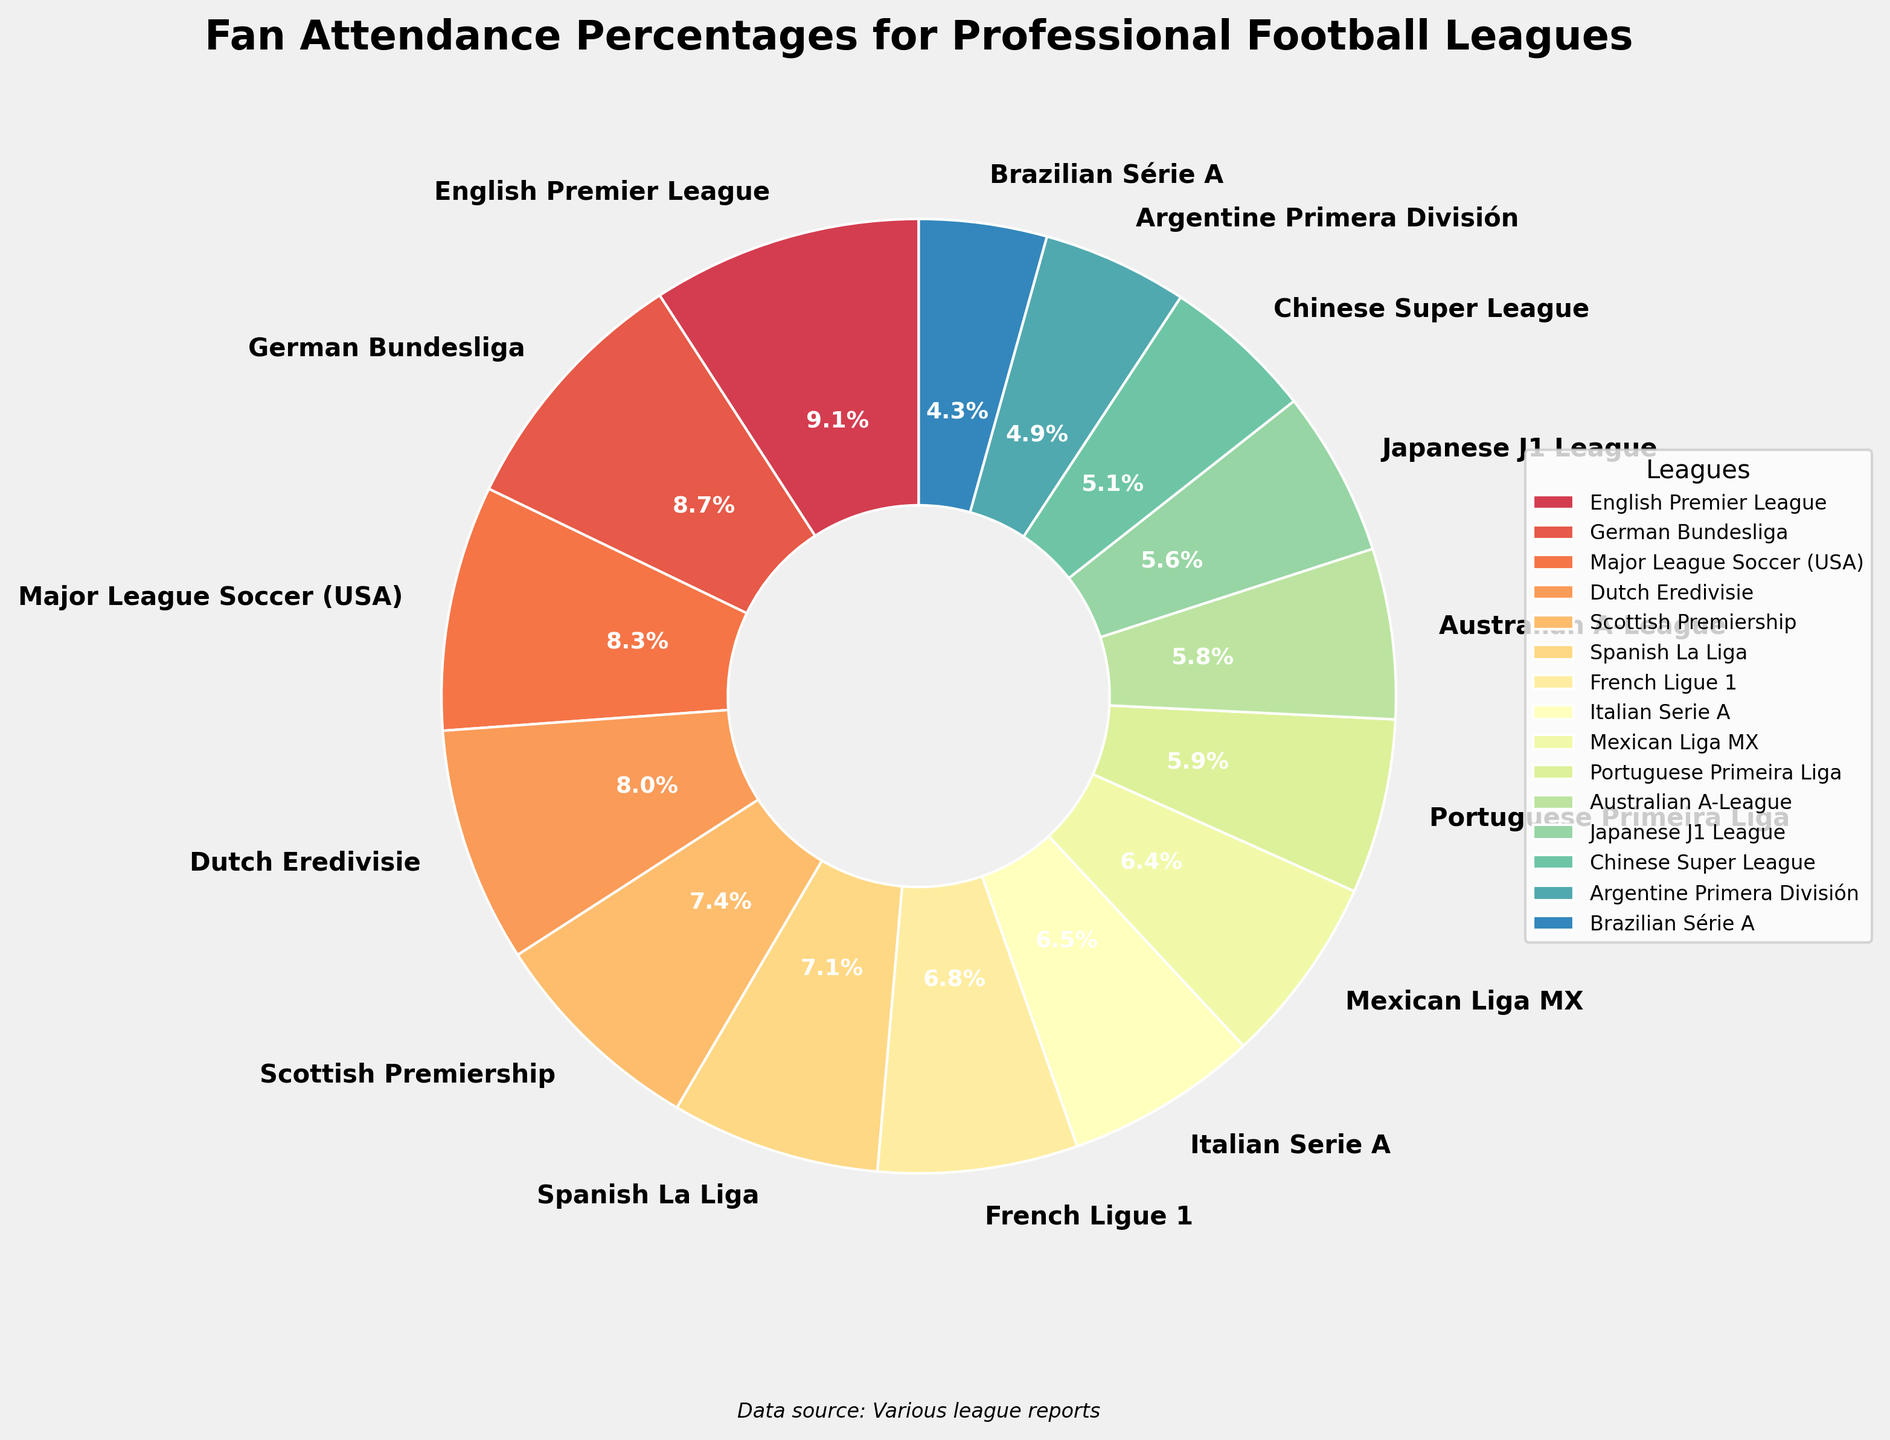Which league has the highest fan attendance percentage? To find the highest fan attendance percentage, look for the league with the largest slice in the pie chart and check its label. The English Premier League has the largest slice with 96.2%.
Answer: English Premier League Which league has the lowest attendance percentage? Identify the smallest slice in the pie chart and look at its label. The Brazilian Série A has the smallest slice with 45.6%.
Answer: Brazilian Série A What's the difference in attendance percentage between the English Premier League and the Spanish La Liga? The English Premier League's attendance percentage is 96.2%, and the Spanish La Liga's is 74.5%. Subtract the smaller value from the larger one: 96.2% - 74.5% = 21.7%.
Answer: 21.7% Which league has a higher attendance percentage, Major League Soccer or Italian Serie A? Compare the slices labeled Major League Soccer (87.5%) and Italian Serie A (68.7%). Major League Soccer has a higher percentage.
Answer: Major League Soccer What's the combined attendance percentage for the leagues with the three lowest attendance percentages? Locate the three smallest slices: Brazilian Série A (45.6%), Argentine Primera División (51.8%), and Chinese Super League (54.2%). Add these percentages: 45.6% + 51.8% + 54.2% = 151.6%.
Answer: 151.6% How does the attendance percentage for the Dutch Eredivisie compare to that of the Scottish Premiership? Check the slices for Dutch Eredivisie (83.9%) and Scottish Premiership (78.2%). The Dutch Eredivisie has a higher attendance percentage.
Answer: Dutch Eredivisie What's the average attendance percentage of the top 5 leagues by attendance? The top 5 leagues by attendance percentages are English Premier League (96.2%), German Bundesliga (91.8%), Major League Soccer (87.5%), Dutch Eredivisie (83.9%), and Scottish Premiership (78.2%). Calculate the average: (96.2% + 91.8% + 87.5% + 83.9% + 78.2%) / 5 = 87.52%.
Answer: 87.52% Which league's attendance percentage is just greater than the Japanese J1 League? Find the percentage for Japanese J1 League (59.1%) and then locate the next immediate higher percentage, which is the Australian A-League (60.8%).
Answer: Australian A-League What's the total percentage of fan attendance for all European leagues combined? Identify the European leagues and sum their percentages: EPL (96.2%), Bundesliga (91.8%), La Liga (74.5%), Serie A (68.7%), Ligue 1 (71.3%), Eredivisie (83.9%), Scottish Premiership (78.2%), and Primeira Liga (62.4%): 96.2 + 91.8 + 74.5 + 68.7 + 71.3 + 83.9 + 78.2 + 62.4 = 627%.
Answer: 627% Out of the given leagues, which ones have attendance percentages higher than 80%? Examine all the slices and identify those with percentages greater than 80%. The leagues are: English Premier League (96.2%), German Bundesliga (91.8%), Major League Soccer (87.5%), and Dutch Eredivisie (83.9%).
Answer: English Premier League, German Bundesliga, Major League Soccer, Dutch Eredivisie 